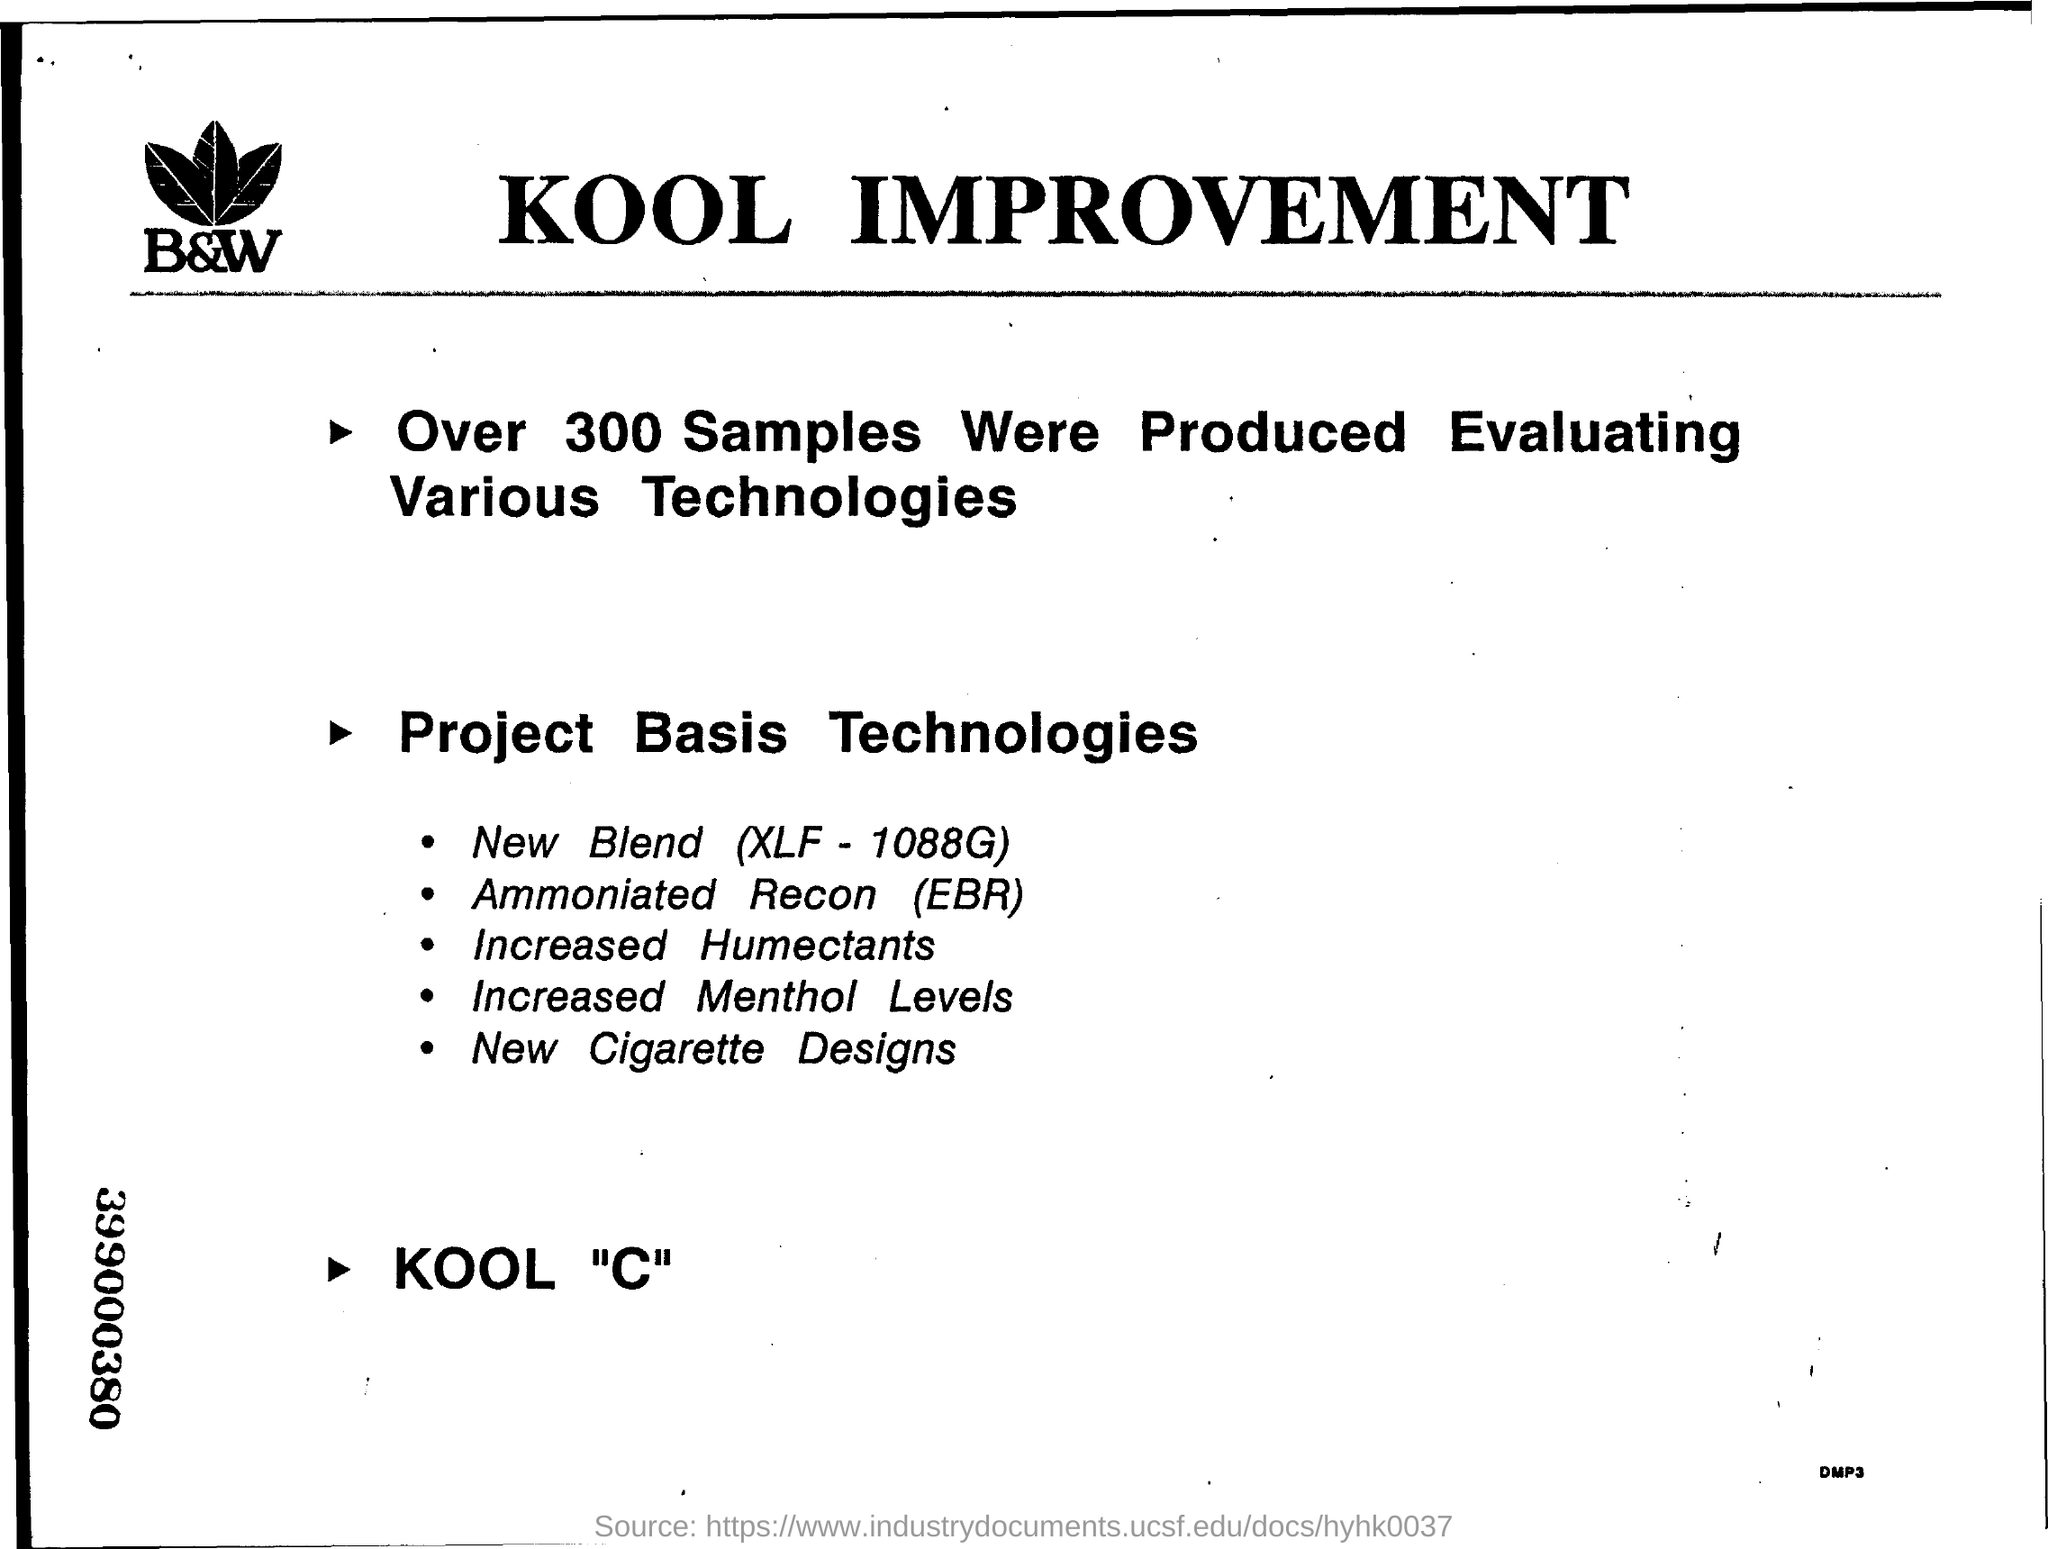Draw attention to some important aspects in this diagram. The 9-digit number located on the left border at the bottom is 399000380. This document is about a KOOL improvement. The production of samples exceeded 300. The third point mentioned in Project Basis Technologies is increased humectants, which refers to the use of humectants to increase the moisture content of a product. 